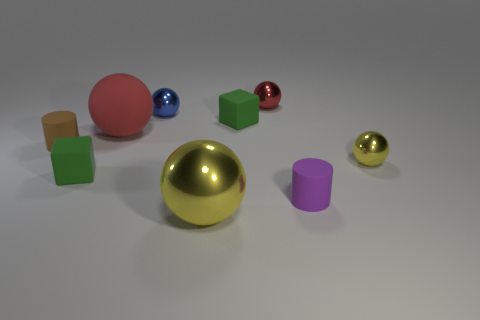Are there any patterns or symmetry in the arrangement of the objects? The arrangement of objects doesn't follow a strict pattern or symmetry. The items are placed randomly across the surface, with varying distances between them, creating an asymmetrical and spontaneous layout. 